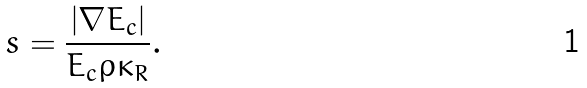<formula> <loc_0><loc_0><loc_500><loc_500>s = \frac { | \nabla E _ { c } | } { E _ { c } \rho \kappa _ { R } } .</formula> 